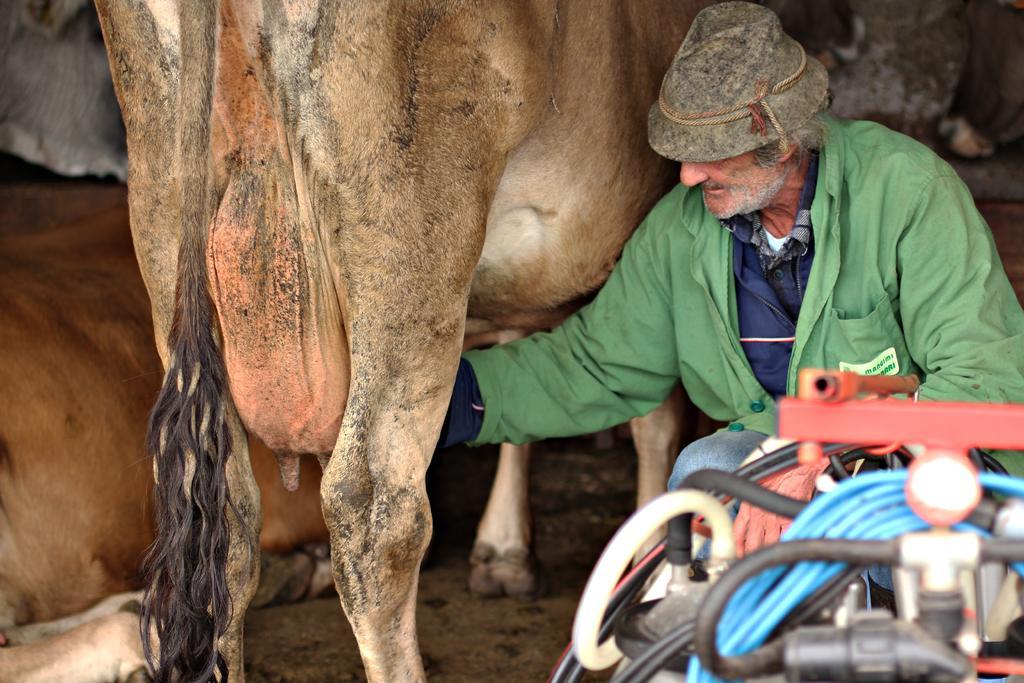Please provide a concise description of this image. In this picture there are two animals and there is a person wearing green dress is crouching beside it and there are some other objects in the right bottom corner. 